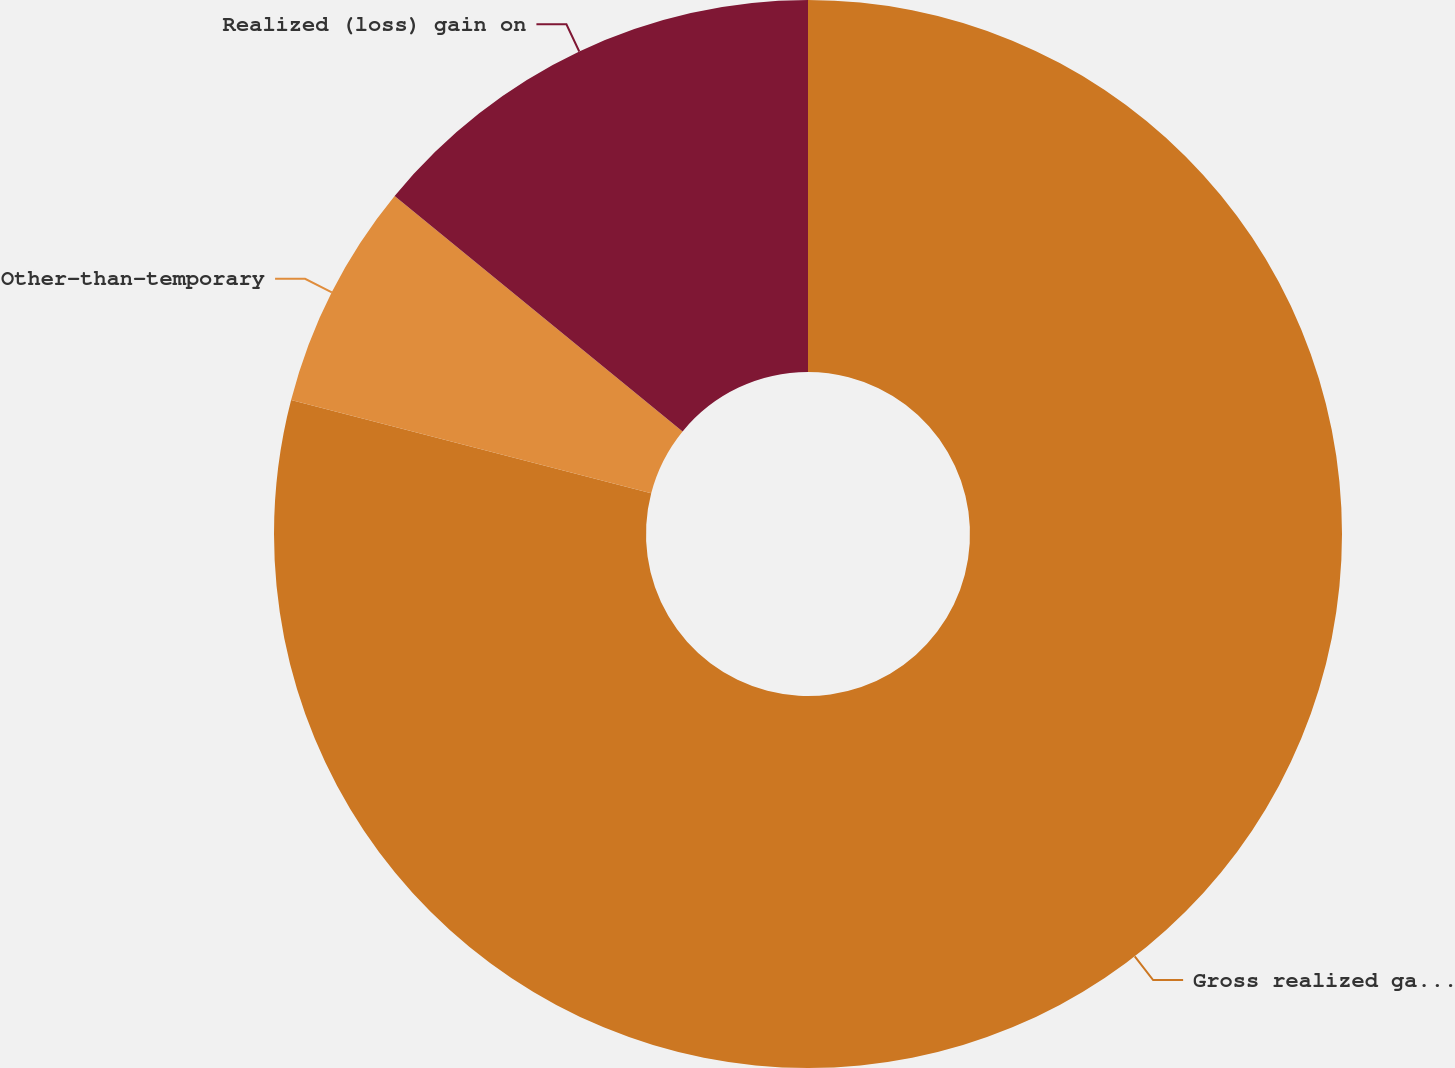Convert chart to OTSL. <chart><loc_0><loc_0><loc_500><loc_500><pie_chart><fcel>Gross realized gain on sale of<fcel>Other-than-temporary<fcel>Realized (loss) gain on<nl><fcel>79.04%<fcel>6.87%<fcel>14.09%<nl></chart> 